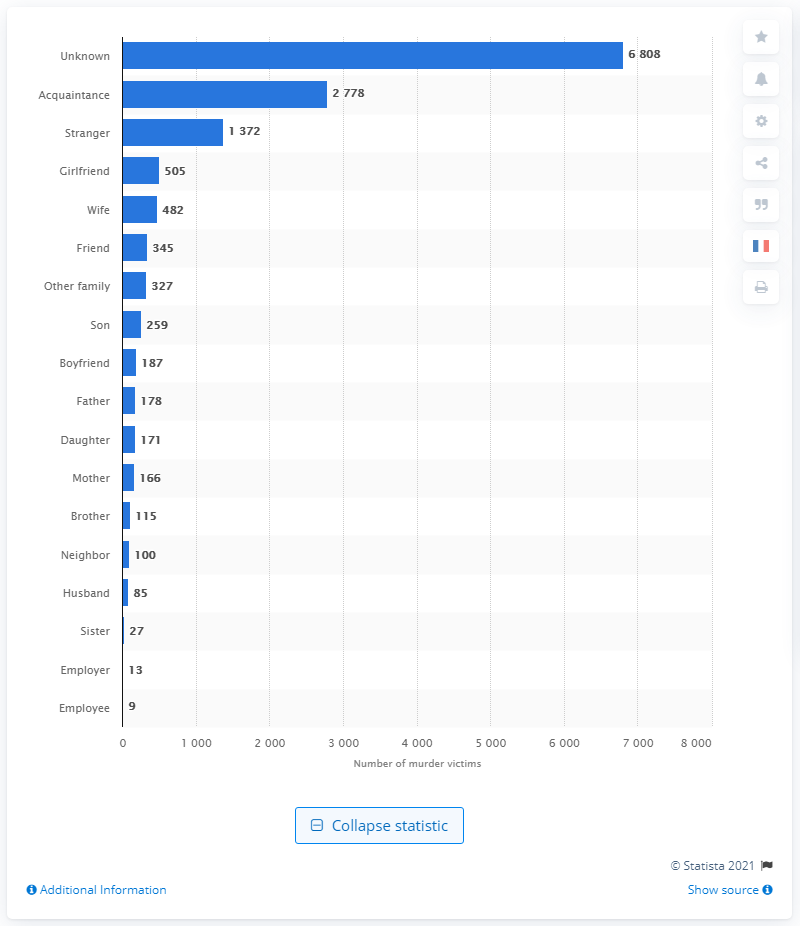List a handful of essential elements in this visual. In 2019, 13 people were murdered by their employer. 